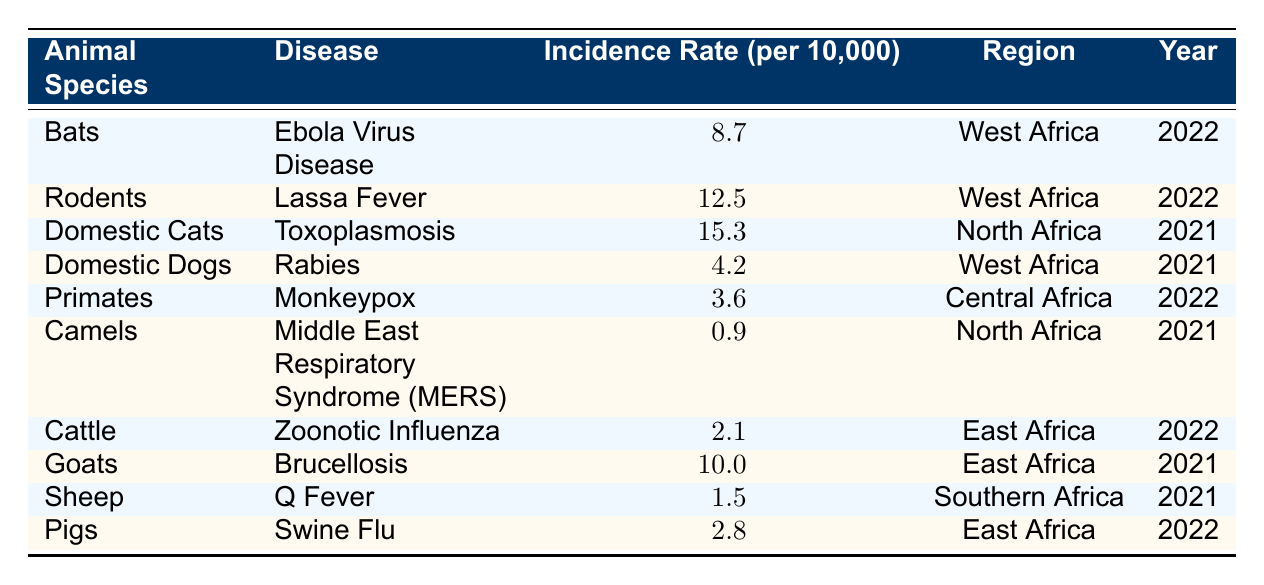What is the highest incidence rate for a zoonotic disease in the table? The table shows the incidence rates for each disease. The maximum value is 15.3 for Domestic Cats with Toxoplasmosis.
Answer: 15.3 In which region did Lassa Fever occur, and what was its incidence rate? The table lists Lassa Fever under Rodents with an incidence rate of 12.5 in West Africa.
Answer: West Africa, 12.5 Which animal species is associated with the lowest incidence rate, and what is that rate? By examining the table, it is clear that Camels have the lowest incidence rate at 0.9 associated with MERS in North Africa.
Answer: Camels, 0.9 What is the average incidence rate of zoonotic diseases in East Africa based on the table? The rates for East Africa are 2.1 (Cattle) and 2.8 (Pigs). The sum is 2.1 + 2.8 = 4.9, and the average is 4.9/2 = 2.45.
Answer: 2.45 Is it true that Rabies has a higher incidence rate than Monkeypox? The incidence rate for Rabies in Domestic Dogs is 4.2, while Monkeypox in Primates is 3.6. Therefore, the statement is true.
Answer: Yes How many types of animals listed have an incidence rate above 10 per 10,000? By counting the rates from the table, we find that 3 species (Rodents, Domestic Cats, Goats) have rates above 10.
Answer: 3 What is the difference in incidence rates between Toxoplasmosis and Rabies? Toxoplasmosis has an incidence rate of 15.3 and Rabies has 4.2. The difference is 15.3 - 4.2 = 11.1.
Answer: 11.1 Which zoonotic diseases occurred in 2022, and what were their incidence rates? From the table, the diseases in 2022 are Ebola Virus Disease (8.7), Lassa Fever (12.5), Monkeypox (3.6), Zoonotic Influenza (2.1), and Swine Flu (2.8).
Answer: Ebola Virus Disease (8.7), Lassa Fever (12.5), Monkeypox (3.6), Zoonotic Influenza (2.1), Swine Flu (2.8) Which animal species are linked to zoonotic diseases that have an incidence rate below 3? The table indicates that the only species with incidence rates below 3 is Camels with 0.9 and Sheep with 1.5.
Answer: Camels, Sheep What percentage of the total zoonotic diseases listed in the table is represented by cases of Toxoplasmosis? Toxoplasmosis has an incidence rate of 15.3, and the total of all rates is 8.7 + 12.5 + 15.3 + 4.2 + 3.6 + 0.9 + 2.1 + 10.0 + 1.5 + 2.8 = 61.6. The percentage is (15.3 / 61.6) * 100 ≈ 24.83%.
Answer: 24.83% 